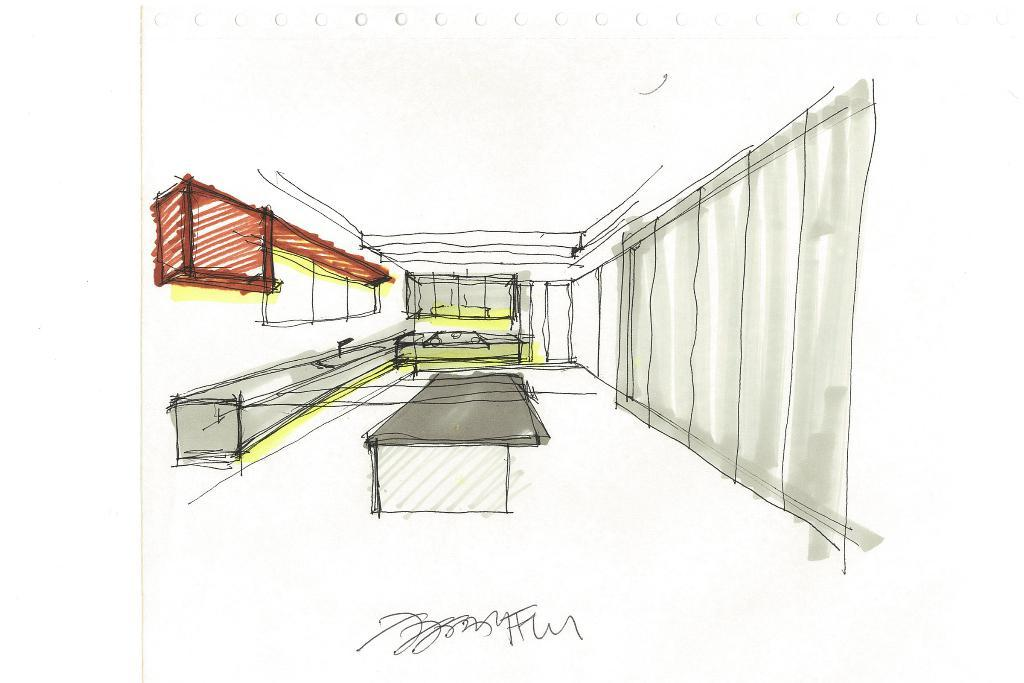What is depicted in the image? The image contains a sketch of a room. Can you describe the contents of the room? There are few items present in the room. What type of animal can be seen in the room in the image? There is no animal present in the room depicted in the image. How many cents are visible on the floor in the image? There are no cents visible in the image, as it is a sketch of a room with few items present. 